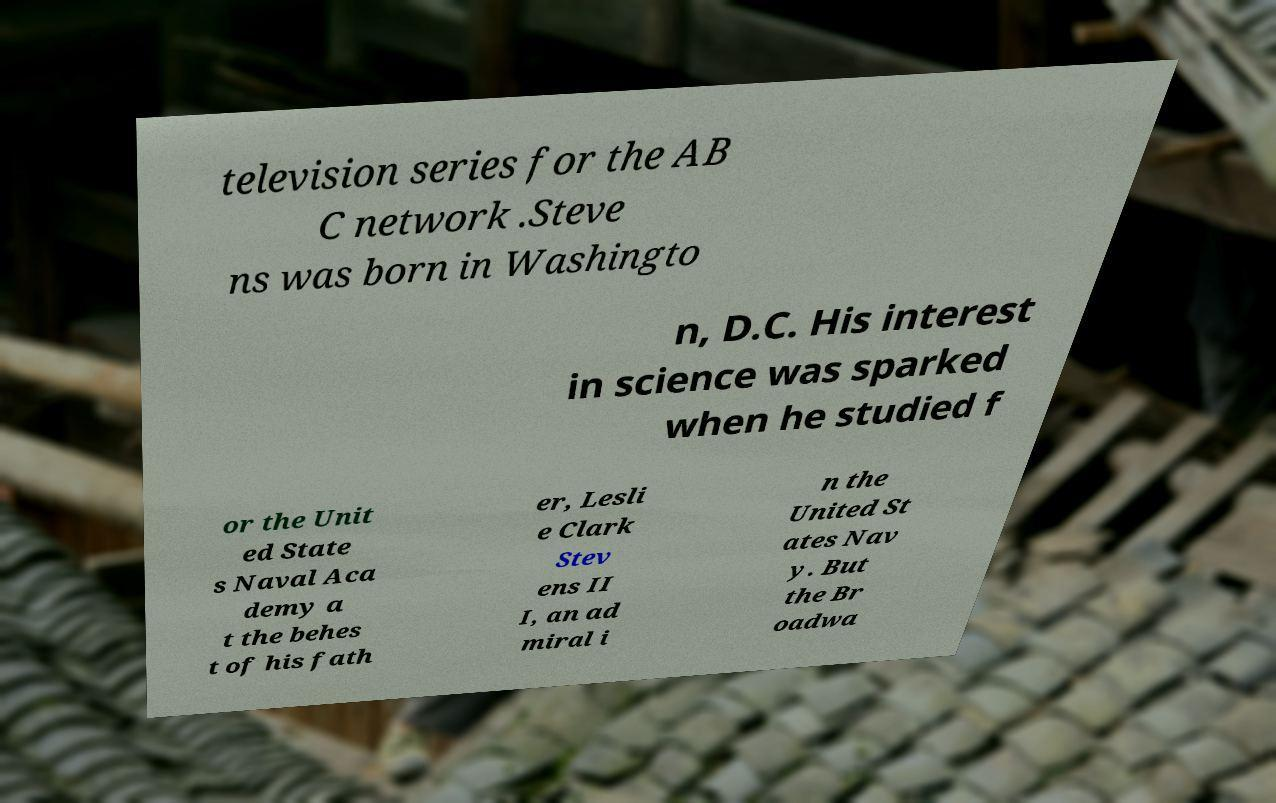Could you extract and type out the text from this image? television series for the AB C network .Steve ns was born in Washingto n, D.C. His interest in science was sparked when he studied f or the Unit ed State s Naval Aca demy a t the behes t of his fath er, Lesli e Clark Stev ens II I, an ad miral i n the United St ates Nav y. But the Br oadwa 